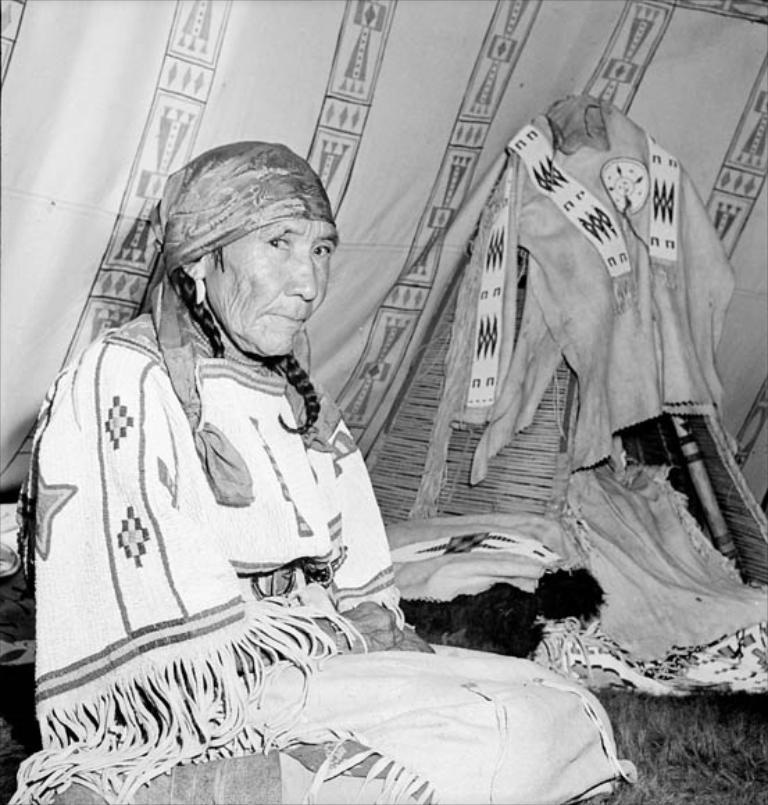Please provide a concise description of this image. In front of the image there is a woman sitting on the grass surface, behind the woman there is some cloth, objects and a tent. 